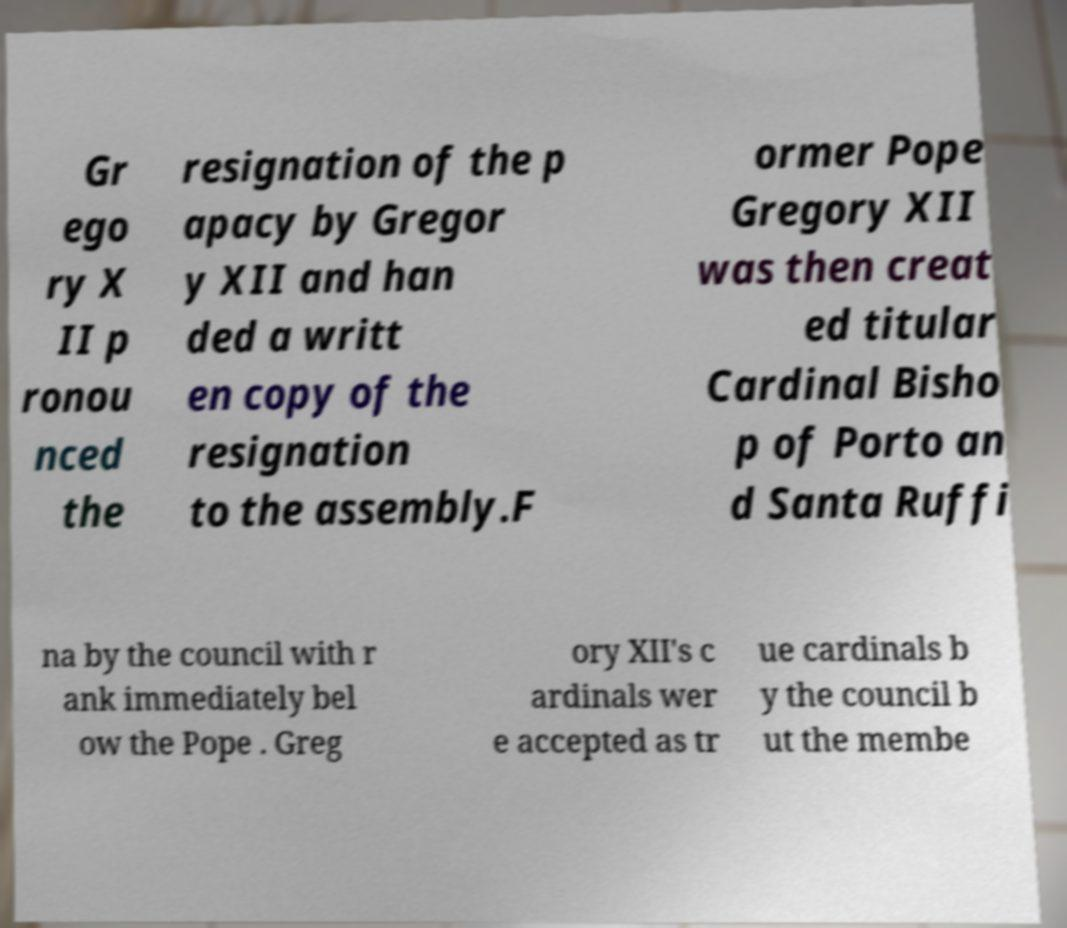Could you extract and type out the text from this image? Gr ego ry X II p ronou nced the resignation of the p apacy by Gregor y XII and han ded a writt en copy of the resignation to the assembly.F ormer Pope Gregory XII was then creat ed titular Cardinal Bisho p of Porto an d Santa Ruffi na by the council with r ank immediately bel ow the Pope . Greg ory XII's c ardinals wer e accepted as tr ue cardinals b y the council b ut the membe 